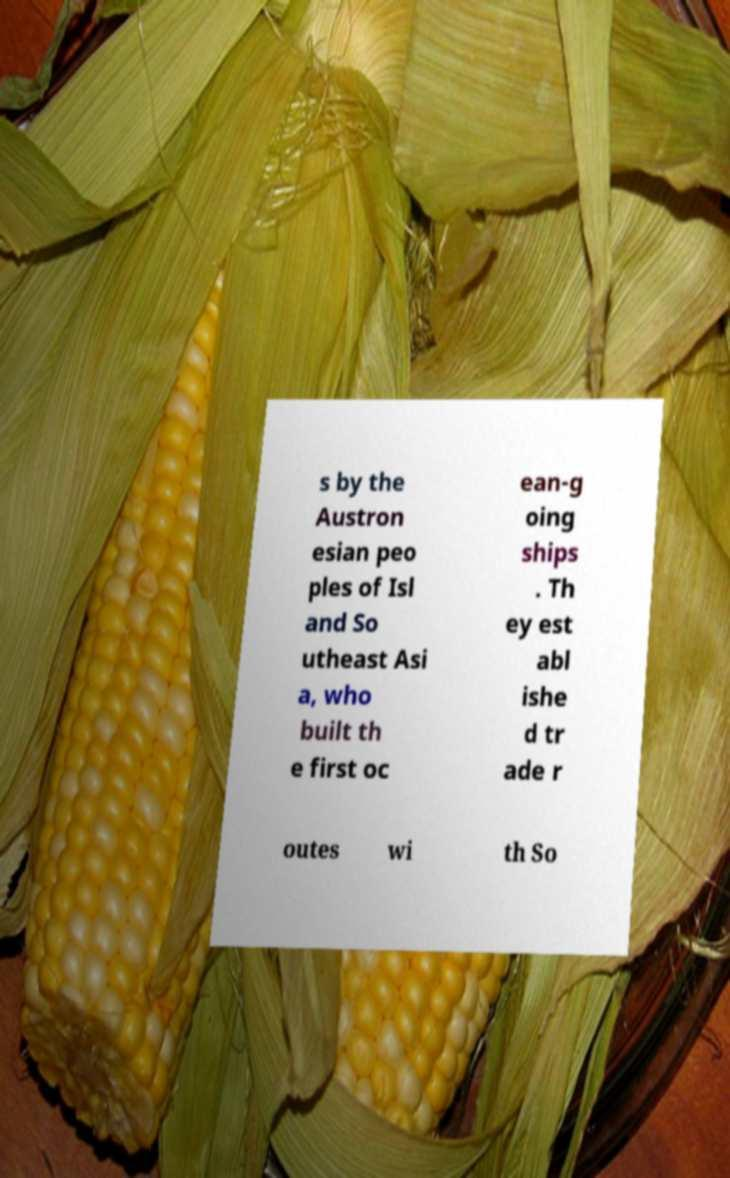Can you accurately transcribe the text from the provided image for me? s by the Austron esian peo ples of Isl and So utheast Asi a, who built th e first oc ean-g oing ships . Th ey est abl ishe d tr ade r outes wi th So 